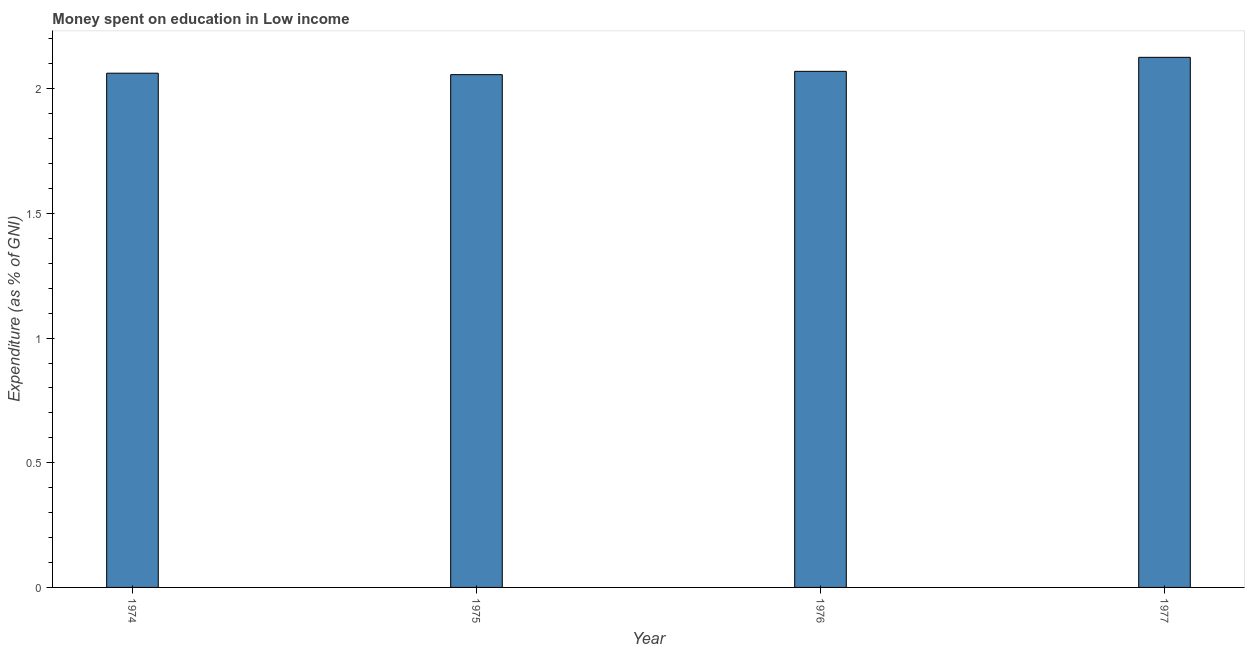Does the graph contain any zero values?
Give a very brief answer. No. Does the graph contain grids?
Your answer should be very brief. No. What is the title of the graph?
Make the answer very short. Money spent on education in Low income. What is the label or title of the Y-axis?
Make the answer very short. Expenditure (as % of GNI). What is the expenditure on education in 1974?
Provide a short and direct response. 2.06. Across all years, what is the maximum expenditure on education?
Provide a short and direct response. 2.13. Across all years, what is the minimum expenditure on education?
Provide a succinct answer. 2.06. In which year was the expenditure on education maximum?
Your response must be concise. 1977. In which year was the expenditure on education minimum?
Give a very brief answer. 1975. What is the sum of the expenditure on education?
Ensure brevity in your answer.  8.31. What is the difference between the expenditure on education in 1974 and 1975?
Provide a succinct answer. 0.01. What is the average expenditure on education per year?
Keep it short and to the point. 2.08. What is the median expenditure on education?
Your response must be concise. 2.07. What is the ratio of the expenditure on education in 1974 to that in 1977?
Your response must be concise. 0.97. Is the expenditure on education in 1975 less than that in 1976?
Give a very brief answer. Yes. What is the difference between the highest and the second highest expenditure on education?
Give a very brief answer. 0.06. What is the difference between the highest and the lowest expenditure on education?
Offer a terse response. 0.07. How many bars are there?
Give a very brief answer. 4. What is the Expenditure (as % of GNI) in 1974?
Provide a succinct answer. 2.06. What is the Expenditure (as % of GNI) in 1975?
Provide a succinct answer. 2.06. What is the Expenditure (as % of GNI) in 1976?
Your response must be concise. 2.07. What is the Expenditure (as % of GNI) of 1977?
Keep it short and to the point. 2.13. What is the difference between the Expenditure (as % of GNI) in 1974 and 1975?
Offer a very short reply. 0.01. What is the difference between the Expenditure (as % of GNI) in 1974 and 1976?
Keep it short and to the point. -0.01. What is the difference between the Expenditure (as % of GNI) in 1974 and 1977?
Ensure brevity in your answer.  -0.06. What is the difference between the Expenditure (as % of GNI) in 1975 and 1976?
Keep it short and to the point. -0.01. What is the difference between the Expenditure (as % of GNI) in 1975 and 1977?
Offer a very short reply. -0.07. What is the difference between the Expenditure (as % of GNI) in 1976 and 1977?
Make the answer very short. -0.06. What is the ratio of the Expenditure (as % of GNI) in 1974 to that in 1977?
Provide a succinct answer. 0.97. What is the ratio of the Expenditure (as % of GNI) in 1975 to that in 1976?
Your answer should be very brief. 0.99. What is the ratio of the Expenditure (as % of GNI) in 1975 to that in 1977?
Offer a very short reply. 0.97. 